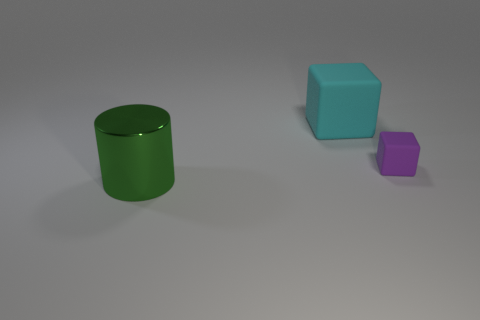Add 3 tiny cyan objects. How many objects exist? 6 Subtract all cylinders. How many objects are left? 2 Add 3 big cylinders. How many big cylinders are left? 4 Add 3 big green cylinders. How many big green cylinders exist? 4 Subtract 0 green blocks. How many objects are left? 3 Subtract all rubber spheres. Subtract all large metal objects. How many objects are left? 2 